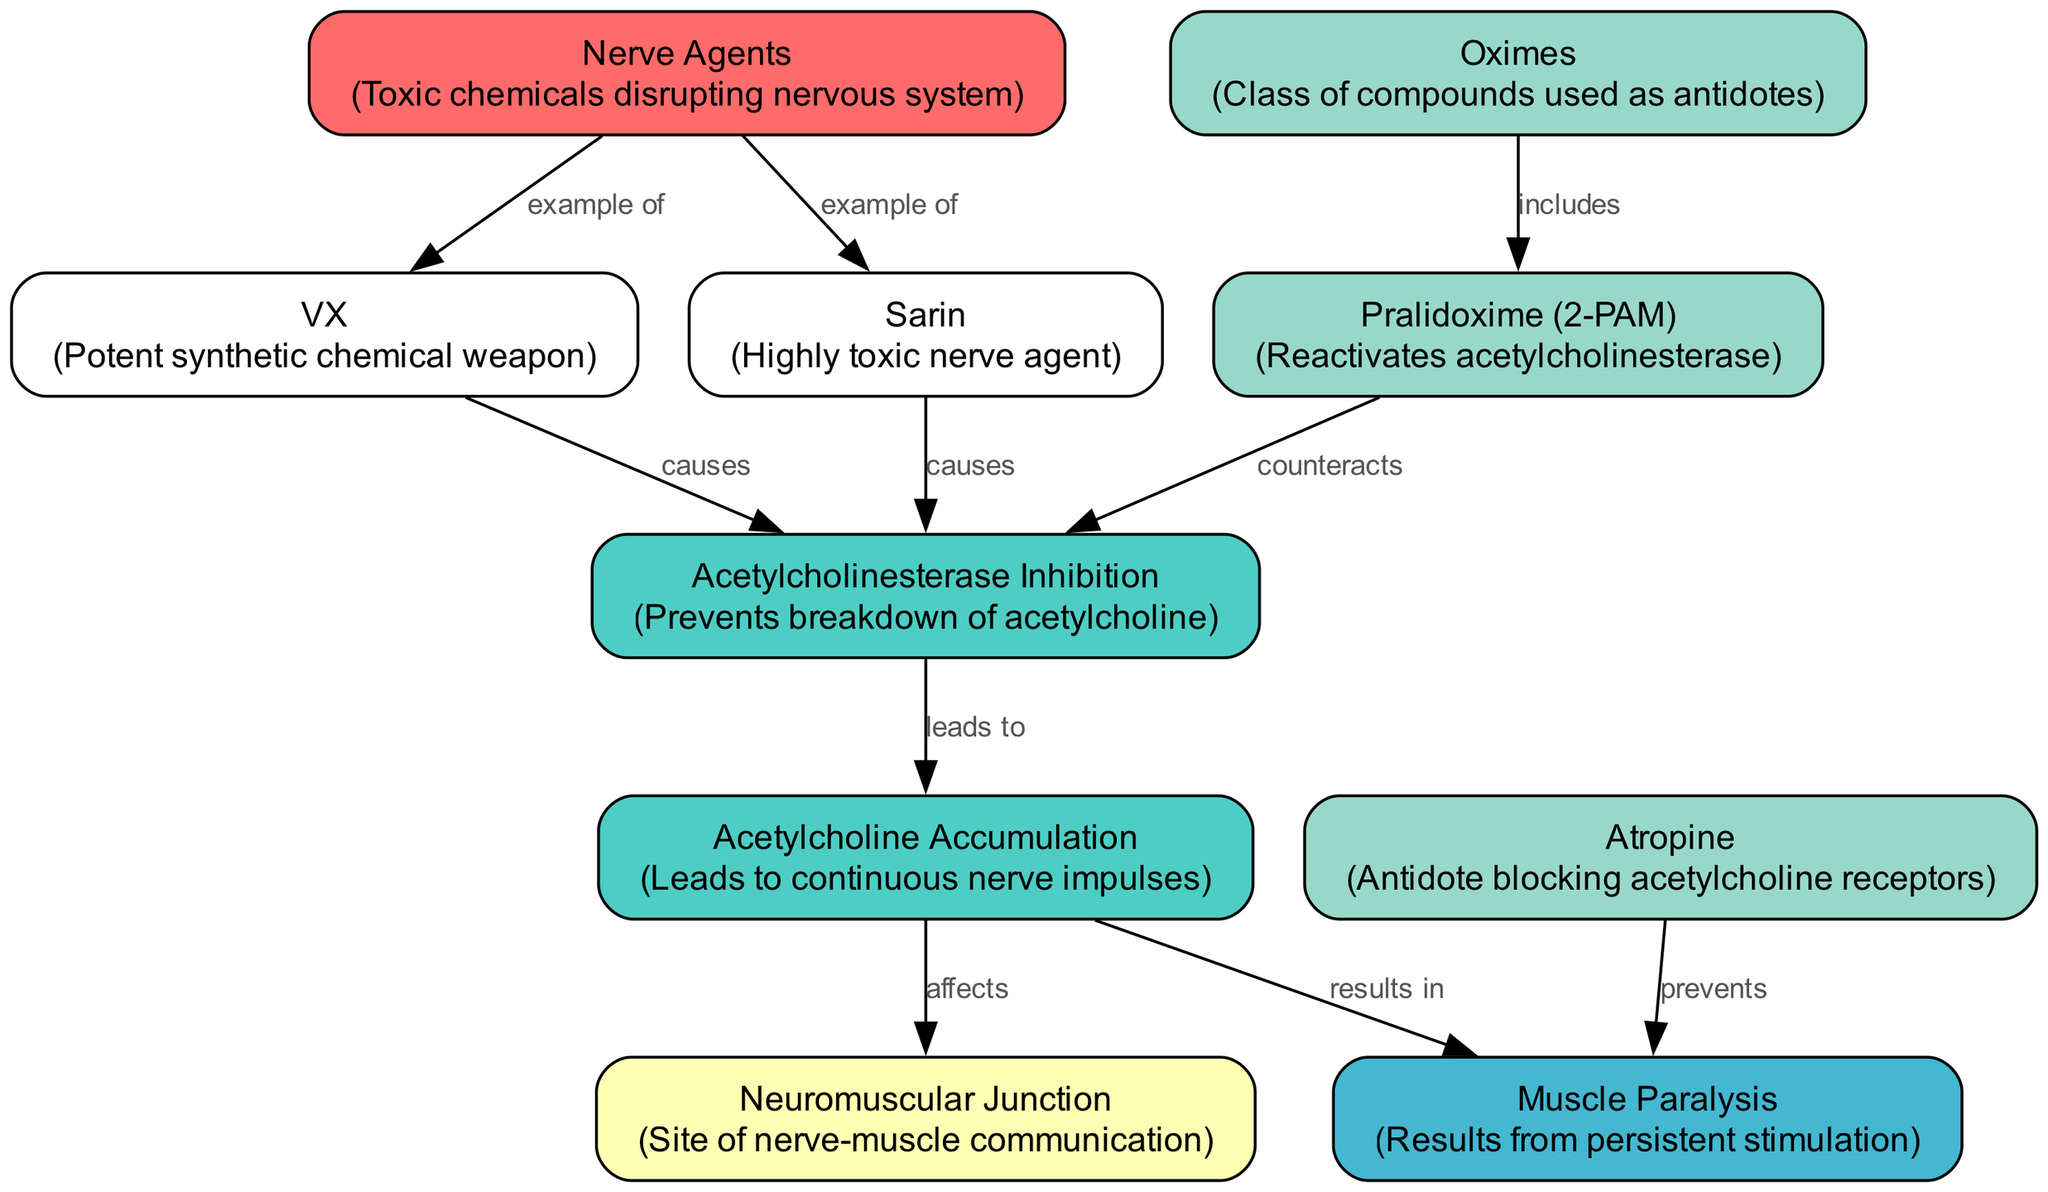What are examples of nerve agents? The diagram includes nodes for Sarin and VX, both of which are specifically identified as examples of nerve agents.
Answer: Sarin, VX What does acetylcholinesterase inhibition cause? The diagram shows that acetylcholinesterase inhibition leads to the accumulation of acetylcholine, based on the directional relationship between these nodes.
Answer: Acetylcholine accumulation How many antidotes are listed in the diagram? The diagram includes three antidotes: Atropine, Pralidoxime (2-PAM), and Oximes. Counting these nodes gives the answer.
Answer: 3 What effect does acetylcholine accumulation have on muscles? According to the diagram, acetylcholine accumulation results in muscle paralysis, as indicated by the direct relationship between those two nodes.
Answer: Muscle paralysis What does Pralidoxime counteract? The diagram indicates that Pralidoxime counteracts acetylcholinesterase inhibition, as seen from the directed edge connecting these two nodes.
Answer: Acetylcholinesterase inhibition What is the connection between muscle paralysis and atropine? The diagram shows that Atropine prevents muscle paralysis by blocking acetylcholine receptors, indicating a protective mechanism against muscle effects.
Answer: Prevents Which site is affected by acetylcholine accumulation? The diagram indicates that the neuromuscular junction is affected by acetylcholine accumulation, as it is linked to that node.
Answer: Neuromuscular junction What class of compounds includes Pralidoxime? The diagram clearly states that Pralidoxime is included as part of the class of compounds known as oximes.
Answer: Oximes 